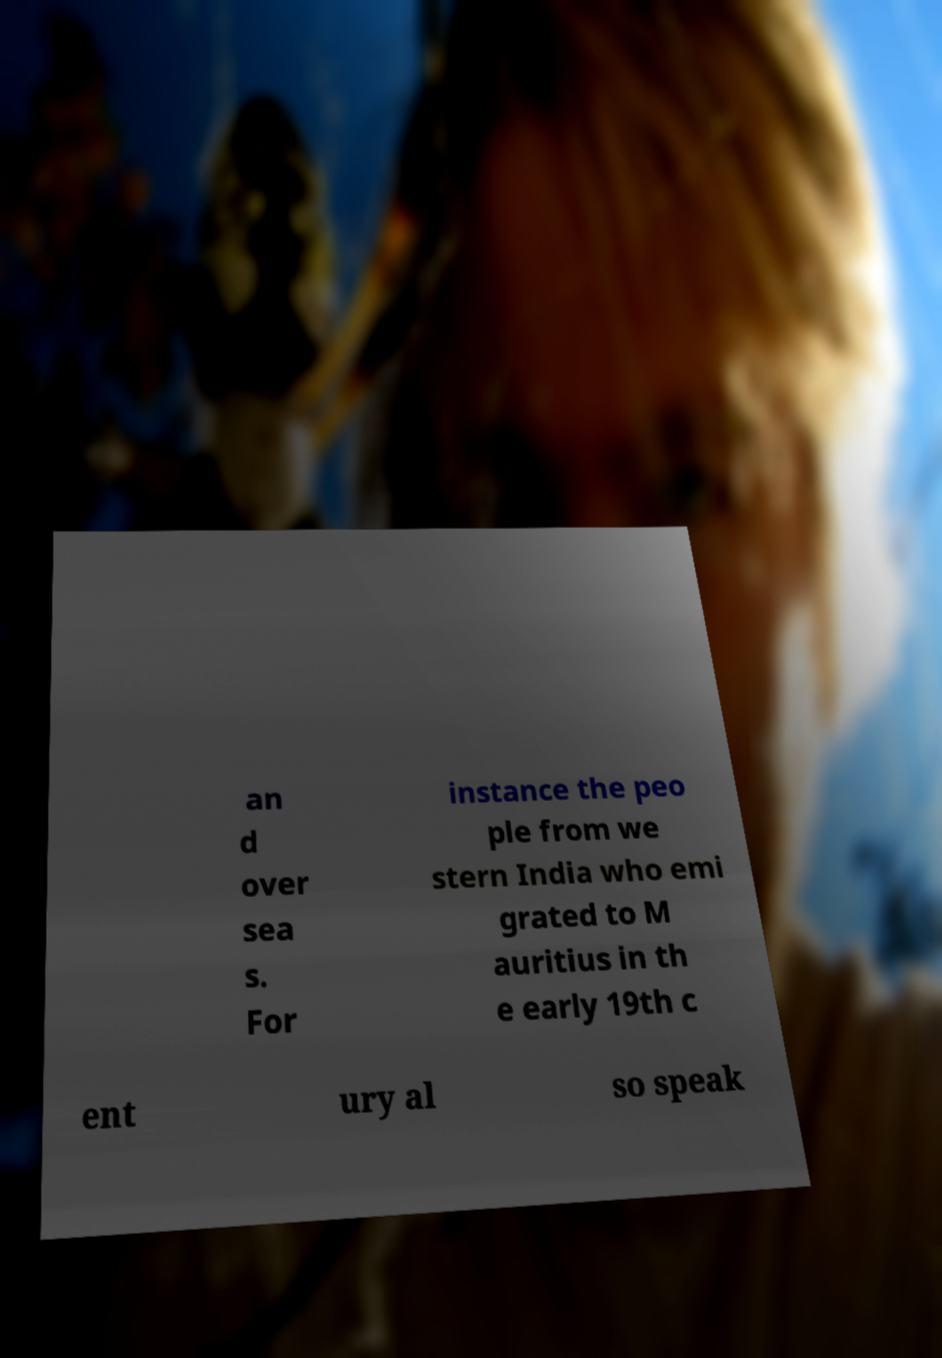For documentation purposes, I need the text within this image transcribed. Could you provide that? an d over sea s. For instance the peo ple from we stern India who emi grated to M auritius in th e early 19th c ent ury al so speak 